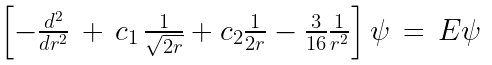Convert formula to latex. <formula><loc_0><loc_0><loc_500><loc_500>\begin{array} { l } \left [ - \frac { d ^ { 2 } } { d r ^ { 2 } } \, + \, c _ { 1 } \, \frac { 1 } { \sqrt { 2 r } } + c _ { 2 } \frac { 1 } { 2 r } - \frac { 3 } { 1 6 } \frac { 1 } { r ^ { 2 } } \right ] \psi \, = \, E \psi \end{array}</formula> 